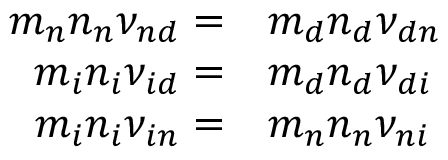Convert formula to latex. <formula><loc_0><loc_0><loc_500><loc_500>\begin{array} { r l } { m _ { n } { n _ { n } } { \nu _ { n d } } = } & m _ { d } { n _ { d } } { \nu _ { d n } } } \\ { m _ { i } { n _ { i } } { \nu _ { i d } } = } & m _ { d } { n _ { d } } { \nu _ { d i } } } \\ { m _ { i } { n _ { i } } { \nu _ { i n } } = } & m _ { n } { n _ { n } } { \nu _ { n i } } } \end{array}</formula> 